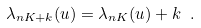Convert formula to latex. <formula><loc_0><loc_0><loc_500><loc_500>\lambda _ { n K + k } ( u ) = \lambda _ { n K } ( u ) + k \ .</formula> 